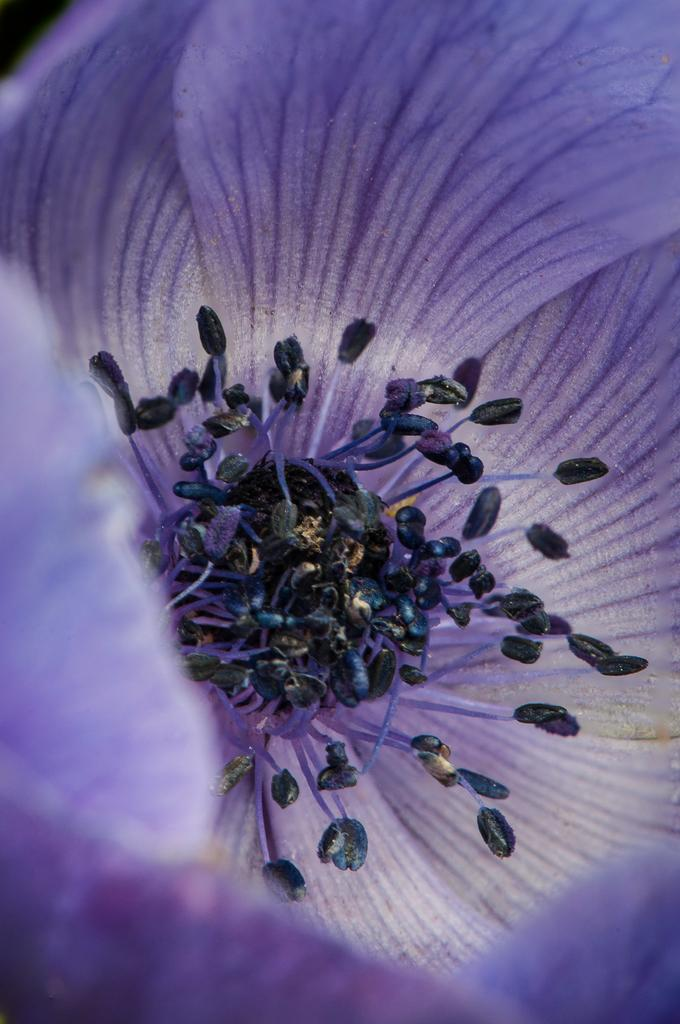What type of flower can be seen in the image? There is there a purple color flower in the image? What type of poison is being used by the friends in the image? There are no friends or poison present in the image; it only features a purple color flower. 